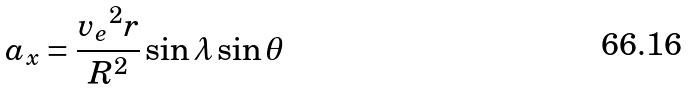<formula> <loc_0><loc_0><loc_500><loc_500>a _ { x } = \frac { { v _ { e } } ^ { 2 } r } { R ^ { 2 } } \sin \lambda \sin \theta</formula> 